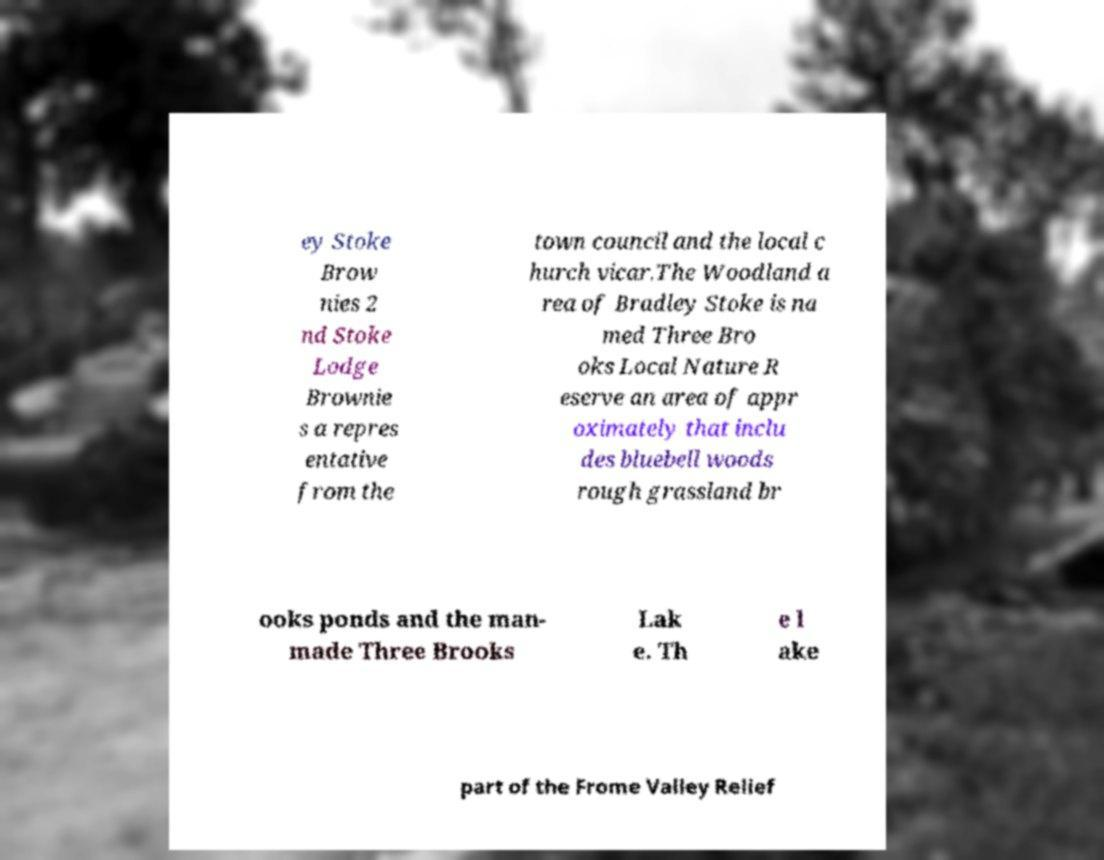For documentation purposes, I need the text within this image transcribed. Could you provide that? ey Stoke Brow nies 2 nd Stoke Lodge Brownie s a repres entative from the town council and the local c hurch vicar.The Woodland a rea of Bradley Stoke is na med Three Bro oks Local Nature R eserve an area of appr oximately that inclu des bluebell woods rough grassland br ooks ponds and the man- made Three Brooks Lak e. Th e l ake part of the Frome Valley Relief 